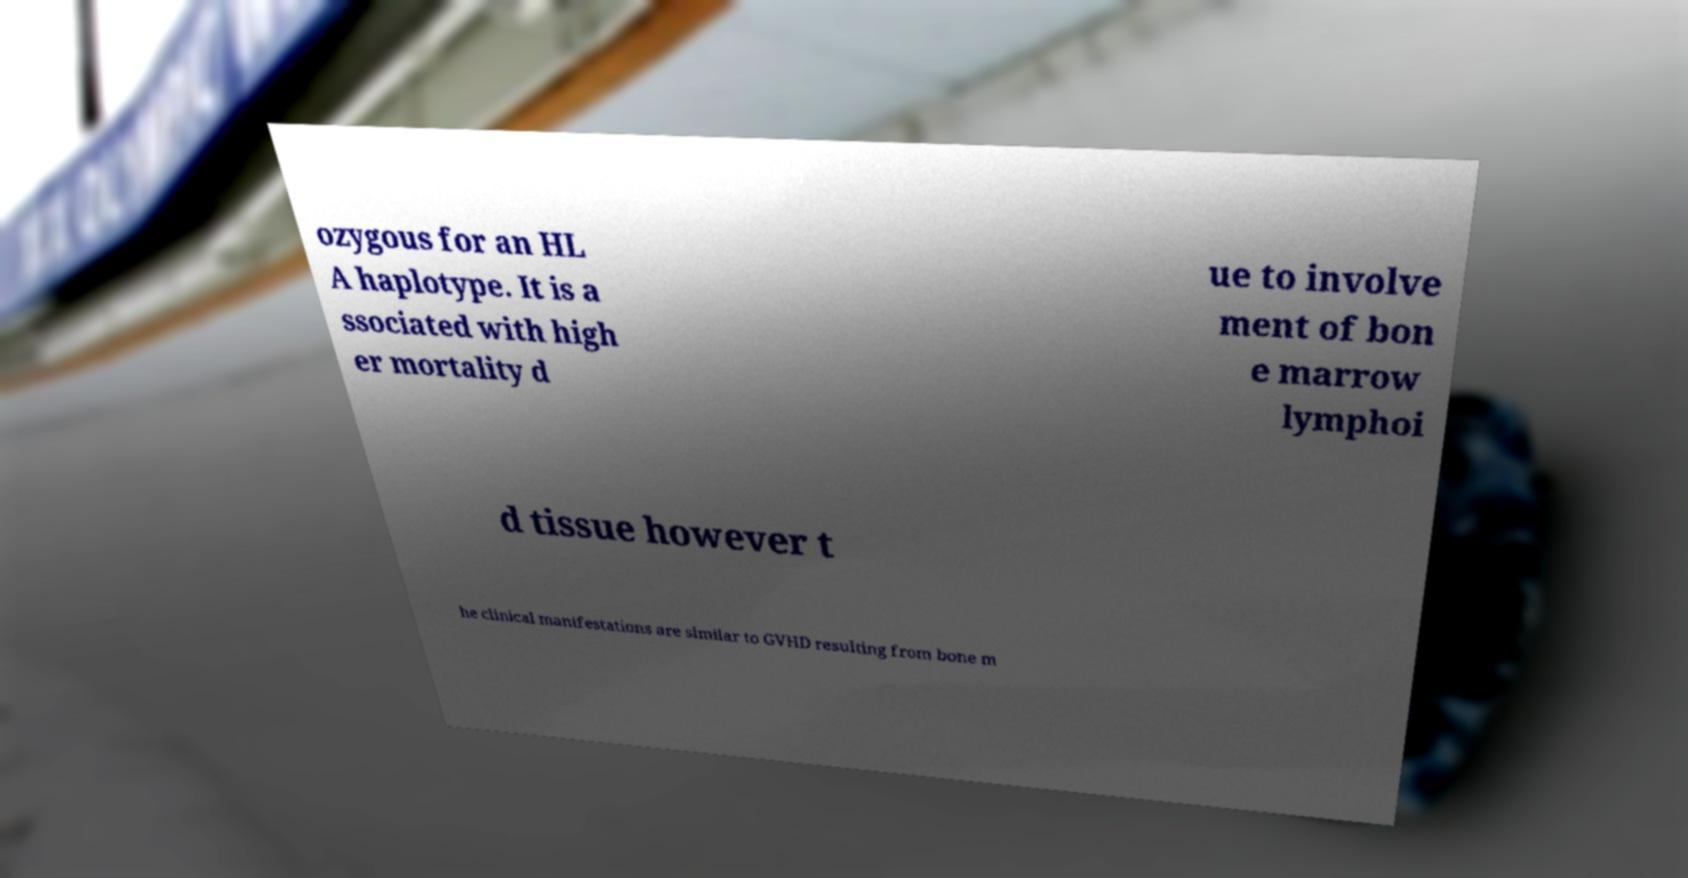I need the written content from this picture converted into text. Can you do that? ozygous for an HL A haplotype. It is a ssociated with high er mortality d ue to involve ment of bon e marrow lymphoi d tissue however t he clinical manifestations are similar to GVHD resulting from bone m 